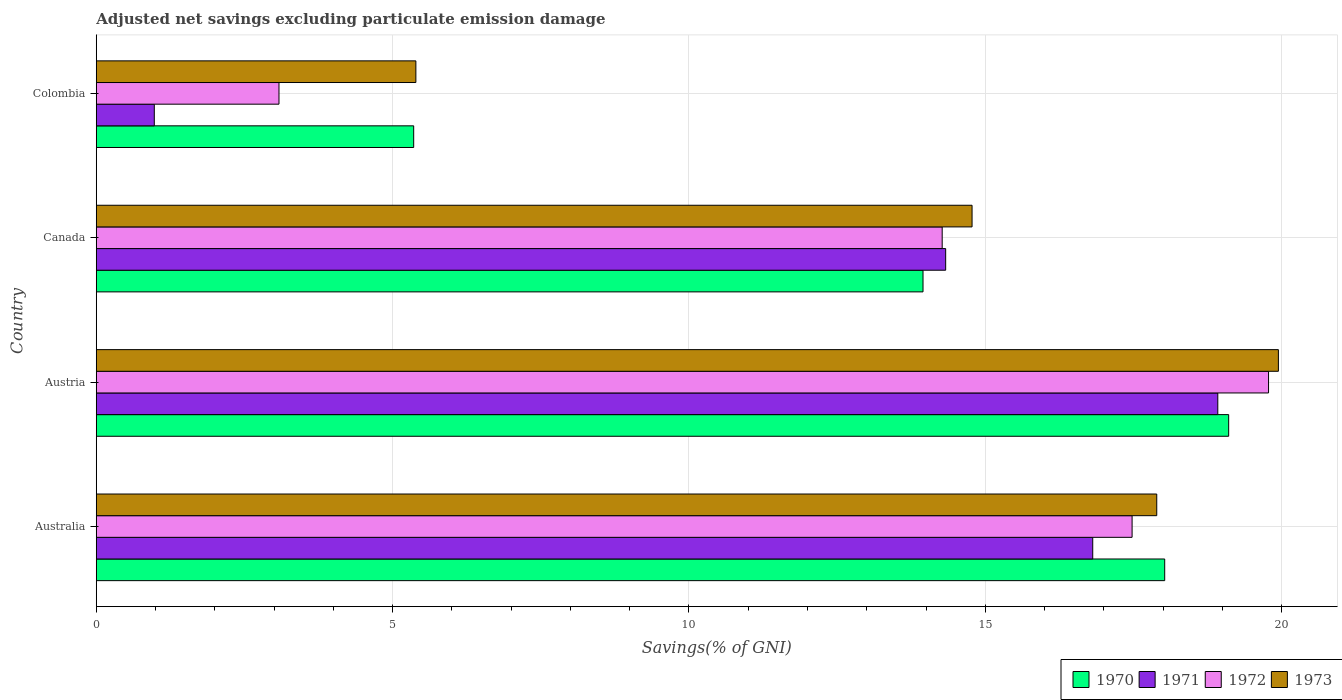How many different coloured bars are there?
Offer a very short reply. 4. Are the number of bars on each tick of the Y-axis equal?
Make the answer very short. Yes. How many bars are there on the 4th tick from the bottom?
Make the answer very short. 4. What is the label of the 4th group of bars from the top?
Provide a short and direct response. Australia. In how many cases, is the number of bars for a given country not equal to the number of legend labels?
Your response must be concise. 0. What is the adjusted net savings in 1970 in Colombia?
Your answer should be compact. 5.36. Across all countries, what is the maximum adjusted net savings in 1971?
Give a very brief answer. 18.92. Across all countries, what is the minimum adjusted net savings in 1971?
Provide a succinct answer. 0.98. In which country was the adjusted net savings in 1971 maximum?
Your response must be concise. Austria. What is the total adjusted net savings in 1970 in the graph?
Provide a short and direct response. 56.44. What is the difference between the adjusted net savings in 1970 in Austria and that in Canada?
Your answer should be compact. 5.16. What is the difference between the adjusted net savings in 1970 in Colombia and the adjusted net savings in 1972 in Canada?
Offer a very short reply. -8.92. What is the average adjusted net savings in 1973 per country?
Keep it short and to the point. 14.5. What is the difference between the adjusted net savings in 1970 and adjusted net savings in 1971 in Canada?
Offer a terse response. -0.38. In how many countries, is the adjusted net savings in 1973 greater than 5 %?
Offer a terse response. 4. What is the ratio of the adjusted net savings in 1972 in Australia to that in Austria?
Provide a short and direct response. 0.88. What is the difference between the highest and the second highest adjusted net savings in 1971?
Give a very brief answer. 2.11. What is the difference between the highest and the lowest adjusted net savings in 1973?
Provide a short and direct response. 14.55. Is it the case that in every country, the sum of the adjusted net savings in 1971 and adjusted net savings in 1973 is greater than the sum of adjusted net savings in 1972 and adjusted net savings in 1970?
Your answer should be very brief. No. What does the 3rd bar from the top in Colombia represents?
Offer a very short reply. 1971. Is it the case that in every country, the sum of the adjusted net savings in 1971 and adjusted net savings in 1973 is greater than the adjusted net savings in 1970?
Your answer should be very brief. Yes. How many bars are there?
Give a very brief answer. 16. Are the values on the major ticks of X-axis written in scientific E-notation?
Your response must be concise. No. Does the graph contain grids?
Provide a succinct answer. Yes. Where does the legend appear in the graph?
Offer a terse response. Bottom right. How are the legend labels stacked?
Ensure brevity in your answer.  Horizontal. What is the title of the graph?
Offer a terse response. Adjusted net savings excluding particulate emission damage. What is the label or title of the X-axis?
Make the answer very short. Savings(% of GNI). What is the Savings(% of GNI) of 1970 in Australia?
Offer a terse response. 18.03. What is the Savings(% of GNI) in 1971 in Australia?
Keep it short and to the point. 16.81. What is the Savings(% of GNI) in 1972 in Australia?
Provide a short and direct response. 17.48. What is the Savings(% of GNI) in 1973 in Australia?
Provide a succinct answer. 17.89. What is the Savings(% of GNI) in 1970 in Austria?
Ensure brevity in your answer.  19.11. What is the Savings(% of GNI) in 1971 in Austria?
Offer a terse response. 18.92. What is the Savings(% of GNI) in 1972 in Austria?
Your answer should be very brief. 19.78. What is the Savings(% of GNI) in 1973 in Austria?
Your answer should be very brief. 19.94. What is the Savings(% of GNI) of 1970 in Canada?
Make the answer very short. 13.95. What is the Savings(% of GNI) in 1971 in Canada?
Your response must be concise. 14.33. What is the Savings(% of GNI) of 1972 in Canada?
Ensure brevity in your answer.  14.27. What is the Savings(% of GNI) in 1973 in Canada?
Provide a short and direct response. 14.78. What is the Savings(% of GNI) in 1970 in Colombia?
Make the answer very short. 5.36. What is the Savings(% of GNI) in 1971 in Colombia?
Your response must be concise. 0.98. What is the Savings(% of GNI) of 1972 in Colombia?
Provide a short and direct response. 3.08. What is the Savings(% of GNI) of 1973 in Colombia?
Provide a short and direct response. 5.39. Across all countries, what is the maximum Savings(% of GNI) in 1970?
Ensure brevity in your answer.  19.11. Across all countries, what is the maximum Savings(% of GNI) in 1971?
Offer a terse response. 18.92. Across all countries, what is the maximum Savings(% of GNI) in 1972?
Your answer should be compact. 19.78. Across all countries, what is the maximum Savings(% of GNI) of 1973?
Provide a succinct answer. 19.94. Across all countries, what is the minimum Savings(% of GNI) in 1970?
Offer a terse response. 5.36. Across all countries, what is the minimum Savings(% of GNI) in 1971?
Provide a succinct answer. 0.98. Across all countries, what is the minimum Savings(% of GNI) of 1972?
Provide a succinct answer. 3.08. Across all countries, what is the minimum Savings(% of GNI) in 1973?
Ensure brevity in your answer.  5.39. What is the total Savings(% of GNI) of 1970 in the graph?
Your response must be concise. 56.44. What is the total Savings(% of GNI) in 1971 in the graph?
Provide a short and direct response. 51.04. What is the total Savings(% of GNI) in 1972 in the graph?
Offer a terse response. 54.61. What is the total Savings(% of GNI) in 1973 in the graph?
Offer a terse response. 58.01. What is the difference between the Savings(% of GNI) in 1970 in Australia and that in Austria?
Provide a succinct answer. -1.08. What is the difference between the Savings(% of GNI) of 1971 in Australia and that in Austria?
Make the answer very short. -2.11. What is the difference between the Savings(% of GNI) of 1972 in Australia and that in Austria?
Give a very brief answer. -2.3. What is the difference between the Savings(% of GNI) of 1973 in Australia and that in Austria?
Your response must be concise. -2.05. What is the difference between the Savings(% of GNI) of 1970 in Australia and that in Canada?
Your answer should be compact. 4.08. What is the difference between the Savings(% of GNI) in 1971 in Australia and that in Canada?
Provide a short and direct response. 2.48. What is the difference between the Savings(% of GNI) of 1972 in Australia and that in Canada?
Your response must be concise. 3.2. What is the difference between the Savings(% of GNI) in 1973 in Australia and that in Canada?
Keep it short and to the point. 3.12. What is the difference between the Savings(% of GNI) in 1970 in Australia and that in Colombia?
Provide a succinct answer. 12.67. What is the difference between the Savings(% of GNI) in 1971 in Australia and that in Colombia?
Your answer should be compact. 15.83. What is the difference between the Savings(% of GNI) in 1972 in Australia and that in Colombia?
Your answer should be compact. 14.39. What is the difference between the Savings(% of GNI) of 1973 in Australia and that in Colombia?
Your response must be concise. 12.5. What is the difference between the Savings(% of GNI) of 1970 in Austria and that in Canada?
Keep it short and to the point. 5.16. What is the difference between the Savings(% of GNI) of 1971 in Austria and that in Canada?
Provide a succinct answer. 4.59. What is the difference between the Savings(% of GNI) of 1972 in Austria and that in Canada?
Offer a very short reply. 5.51. What is the difference between the Savings(% of GNI) in 1973 in Austria and that in Canada?
Make the answer very short. 5.17. What is the difference between the Savings(% of GNI) of 1970 in Austria and that in Colombia?
Give a very brief answer. 13.75. What is the difference between the Savings(% of GNI) in 1971 in Austria and that in Colombia?
Offer a terse response. 17.94. What is the difference between the Savings(% of GNI) of 1972 in Austria and that in Colombia?
Your answer should be compact. 16.7. What is the difference between the Savings(% of GNI) in 1973 in Austria and that in Colombia?
Offer a very short reply. 14.55. What is the difference between the Savings(% of GNI) in 1970 in Canada and that in Colombia?
Keep it short and to the point. 8.59. What is the difference between the Savings(% of GNI) of 1971 in Canada and that in Colombia?
Your response must be concise. 13.35. What is the difference between the Savings(% of GNI) in 1972 in Canada and that in Colombia?
Ensure brevity in your answer.  11.19. What is the difference between the Savings(% of GNI) of 1973 in Canada and that in Colombia?
Make the answer very short. 9.38. What is the difference between the Savings(% of GNI) of 1970 in Australia and the Savings(% of GNI) of 1971 in Austria?
Provide a short and direct response. -0.9. What is the difference between the Savings(% of GNI) of 1970 in Australia and the Savings(% of GNI) of 1972 in Austria?
Make the answer very short. -1.75. What is the difference between the Savings(% of GNI) of 1970 in Australia and the Savings(% of GNI) of 1973 in Austria?
Give a very brief answer. -1.92. What is the difference between the Savings(% of GNI) in 1971 in Australia and the Savings(% of GNI) in 1972 in Austria?
Make the answer very short. -2.97. What is the difference between the Savings(% of GNI) of 1971 in Australia and the Savings(% of GNI) of 1973 in Austria?
Your response must be concise. -3.13. What is the difference between the Savings(% of GNI) of 1972 in Australia and the Savings(% of GNI) of 1973 in Austria?
Ensure brevity in your answer.  -2.47. What is the difference between the Savings(% of GNI) in 1970 in Australia and the Savings(% of GNI) in 1971 in Canada?
Make the answer very short. 3.7. What is the difference between the Savings(% of GNI) in 1970 in Australia and the Savings(% of GNI) in 1972 in Canada?
Your answer should be very brief. 3.75. What is the difference between the Savings(% of GNI) in 1970 in Australia and the Savings(% of GNI) in 1973 in Canada?
Your answer should be compact. 3.25. What is the difference between the Savings(% of GNI) in 1971 in Australia and the Savings(% of GNI) in 1972 in Canada?
Provide a short and direct response. 2.54. What is the difference between the Savings(% of GNI) in 1971 in Australia and the Savings(% of GNI) in 1973 in Canada?
Your answer should be compact. 2.04. What is the difference between the Savings(% of GNI) in 1970 in Australia and the Savings(% of GNI) in 1971 in Colombia?
Your answer should be compact. 17.05. What is the difference between the Savings(% of GNI) in 1970 in Australia and the Savings(% of GNI) in 1972 in Colombia?
Your answer should be very brief. 14.94. What is the difference between the Savings(% of GNI) in 1970 in Australia and the Savings(% of GNI) in 1973 in Colombia?
Keep it short and to the point. 12.63. What is the difference between the Savings(% of GNI) in 1971 in Australia and the Savings(% of GNI) in 1972 in Colombia?
Offer a very short reply. 13.73. What is the difference between the Savings(% of GNI) of 1971 in Australia and the Savings(% of GNI) of 1973 in Colombia?
Provide a succinct answer. 11.42. What is the difference between the Savings(% of GNI) of 1972 in Australia and the Savings(% of GNI) of 1973 in Colombia?
Make the answer very short. 12.08. What is the difference between the Savings(% of GNI) of 1970 in Austria and the Savings(% of GNI) of 1971 in Canada?
Keep it short and to the point. 4.77. What is the difference between the Savings(% of GNI) of 1970 in Austria and the Savings(% of GNI) of 1972 in Canada?
Provide a succinct answer. 4.83. What is the difference between the Savings(% of GNI) in 1970 in Austria and the Savings(% of GNI) in 1973 in Canada?
Offer a very short reply. 4.33. What is the difference between the Savings(% of GNI) in 1971 in Austria and the Savings(% of GNI) in 1972 in Canada?
Offer a very short reply. 4.65. What is the difference between the Savings(% of GNI) of 1971 in Austria and the Savings(% of GNI) of 1973 in Canada?
Your response must be concise. 4.15. What is the difference between the Savings(% of GNI) of 1972 in Austria and the Savings(% of GNI) of 1973 in Canada?
Offer a very short reply. 5. What is the difference between the Savings(% of GNI) in 1970 in Austria and the Savings(% of GNI) in 1971 in Colombia?
Keep it short and to the point. 18.13. What is the difference between the Savings(% of GNI) in 1970 in Austria and the Savings(% of GNI) in 1972 in Colombia?
Your answer should be compact. 16.02. What is the difference between the Savings(% of GNI) of 1970 in Austria and the Savings(% of GNI) of 1973 in Colombia?
Provide a short and direct response. 13.71. What is the difference between the Savings(% of GNI) in 1971 in Austria and the Savings(% of GNI) in 1972 in Colombia?
Offer a terse response. 15.84. What is the difference between the Savings(% of GNI) in 1971 in Austria and the Savings(% of GNI) in 1973 in Colombia?
Ensure brevity in your answer.  13.53. What is the difference between the Savings(% of GNI) of 1972 in Austria and the Savings(% of GNI) of 1973 in Colombia?
Your response must be concise. 14.39. What is the difference between the Savings(% of GNI) of 1970 in Canada and the Savings(% of GNI) of 1971 in Colombia?
Ensure brevity in your answer.  12.97. What is the difference between the Savings(% of GNI) in 1970 in Canada and the Savings(% of GNI) in 1972 in Colombia?
Make the answer very short. 10.87. What is the difference between the Savings(% of GNI) of 1970 in Canada and the Savings(% of GNI) of 1973 in Colombia?
Offer a very short reply. 8.56. What is the difference between the Savings(% of GNI) of 1971 in Canada and the Savings(% of GNI) of 1972 in Colombia?
Provide a succinct answer. 11.25. What is the difference between the Savings(% of GNI) of 1971 in Canada and the Savings(% of GNI) of 1973 in Colombia?
Make the answer very short. 8.94. What is the difference between the Savings(% of GNI) in 1972 in Canada and the Savings(% of GNI) in 1973 in Colombia?
Offer a terse response. 8.88. What is the average Savings(% of GNI) of 1970 per country?
Ensure brevity in your answer.  14.11. What is the average Savings(% of GNI) in 1971 per country?
Make the answer very short. 12.76. What is the average Savings(% of GNI) in 1972 per country?
Ensure brevity in your answer.  13.65. What is the average Savings(% of GNI) of 1973 per country?
Your response must be concise. 14.5. What is the difference between the Savings(% of GNI) in 1970 and Savings(% of GNI) in 1971 in Australia?
Make the answer very short. 1.21. What is the difference between the Savings(% of GNI) in 1970 and Savings(% of GNI) in 1972 in Australia?
Offer a very short reply. 0.55. What is the difference between the Savings(% of GNI) in 1970 and Savings(% of GNI) in 1973 in Australia?
Your response must be concise. 0.13. What is the difference between the Savings(% of GNI) of 1971 and Savings(% of GNI) of 1972 in Australia?
Ensure brevity in your answer.  -0.66. What is the difference between the Savings(% of GNI) in 1971 and Savings(% of GNI) in 1973 in Australia?
Offer a terse response. -1.08. What is the difference between the Savings(% of GNI) in 1972 and Savings(% of GNI) in 1973 in Australia?
Ensure brevity in your answer.  -0.42. What is the difference between the Savings(% of GNI) in 1970 and Savings(% of GNI) in 1971 in Austria?
Give a very brief answer. 0.18. What is the difference between the Savings(% of GNI) of 1970 and Savings(% of GNI) of 1972 in Austria?
Offer a terse response. -0.67. What is the difference between the Savings(% of GNI) of 1970 and Savings(% of GNI) of 1973 in Austria?
Make the answer very short. -0.84. What is the difference between the Savings(% of GNI) of 1971 and Savings(% of GNI) of 1972 in Austria?
Ensure brevity in your answer.  -0.86. What is the difference between the Savings(% of GNI) in 1971 and Savings(% of GNI) in 1973 in Austria?
Offer a terse response. -1.02. What is the difference between the Savings(% of GNI) in 1972 and Savings(% of GNI) in 1973 in Austria?
Offer a terse response. -0.17. What is the difference between the Savings(% of GNI) of 1970 and Savings(% of GNI) of 1971 in Canada?
Provide a succinct answer. -0.38. What is the difference between the Savings(% of GNI) of 1970 and Savings(% of GNI) of 1972 in Canada?
Your answer should be very brief. -0.32. What is the difference between the Savings(% of GNI) in 1970 and Savings(% of GNI) in 1973 in Canada?
Your answer should be very brief. -0.83. What is the difference between the Savings(% of GNI) of 1971 and Savings(% of GNI) of 1972 in Canada?
Provide a short and direct response. 0.06. What is the difference between the Savings(% of GNI) in 1971 and Savings(% of GNI) in 1973 in Canada?
Provide a succinct answer. -0.45. What is the difference between the Savings(% of GNI) in 1972 and Savings(% of GNI) in 1973 in Canada?
Keep it short and to the point. -0.5. What is the difference between the Savings(% of GNI) in 1970 and Savings(% of GNI) in 1971 in Colombia?
Offer a terse response. 4.38. What is the difference between the Savings(% of GNI) in 1970 and Savings(% of GNI) in 1972 in Colombia?
Offer a terse response. 2.27. What is the difference between the Savings(% of GNI) in 1970 and Savings(% of GNI) in 1973 in Colombia?
Give a very brief answer. -0.04. What is the difference between the Savings(% of GNI) in 1971 and Savings(% of GNI) in 1972 in Colombia?
Give a very brief answer. -2.1. What is the difference between the Savings(% of GNI) of 1971 and Savings(% of GNI) of 1973 in Colombia?
Provide a succinct answer. -4.41. What is the difference between the Savings(% of GNI) of 1972 and Savings(% of GNI) of 1973 in Colombia?
Offer a terse response. -2.31. What is the ratio of the Savings(% of GNI) in 1970 in Australia to that in Austria?
Provide a short and direct response. 0.94. What is the ratio of the Savings(% of GNI) of 1971 in Australia to that in Austria?
Make the answer very short. 0.89. What is the ratio of the Savings(% of GNI) of 1972 in Australia to that in Austria?
Ensure brevity in your answer.  0.88. What is the ratio of the Savings(% of GNI) in 1973 in Australia to that in Austria?
Provide a succinct answer. 0.9. What is the ratio of the Savings(% of GNI) of 1970 in Australia to that in Canada?
Keep it short and to the point. 1.29. What is the ratio of the Savings(% of GNI) in 1971 in Australia to that in Canada?
Ensure brevity in your answer.  1.17. What is the ratio of the Savings(% of GNI) of 1972 in Australia to that in Canada?
Your answer should be compact. 1.22. What is the ratio of the Savings(% of GNI) in 1973 in Australia to that in Canada?
Provide a short and direct response. 1.21. What is the ratio of the Savings(% of GNI) of 1970 in Australia to that in Colombia?
Your answer should be very brief. 3.37. What is the ratio of the Savings(% of GNI) in 1971 in Australia to that in Colombia?
Provide a succinct answer. 17.17. What is the ratio of the Savings(% of GNI) of 1972 in Australia to that in Colombia?
Provide a short and direct response. 5.67. What is the ratio of the Savings(% of GNI) in 1973 in Australia to that in Colombia?
Keep it short and to the point. 3.32. What is the ratio of the Savings(% of GNI) of 1970 in Austria to that in Canada?
Provide a short and direct response. 1.37. What is the ratio of the Savings(% of GNI) of 1971 in Austria to that in Canada?
Provide a short and direct response. 1.32. What is the ratio of the Savings(% of GNI) of 1972 in Austria to that in Canada?
Your answer should be very brief. 1.39. What is the ratio of the Savings(% of GNI) of 1973 in Austria to that in Canada?
Keep it short and to the point. 1.35. What is the ratio of the Savings(% of GNI) in 1970 in Austria to that in Colombia?
Provide a succinct answer. 3.57. What is the ratio of the Savings(% of GNI) in 1971 in Austria to that in Colombia?
Give a very brief answer. 19.32. What is the ratio of the Savings(% of GNI) in 1972 in Austria to that in Colombia?
Ensure brevity in your answer.  6.42. What is the ratio of the Savings(% of GNI) in 1973 in Austria to that in Colombia?
Offer a terse response. 3.7. What is the ratio of the Savings(% of GNI) in 1970 in Canada to that in Colombia?
Your answer should be compact. 2.6. What is the ratio of the Savings(% of GNI) in 1971 in Canada to that in Colombia?
Your answer should be very brief. 14.64. What is the ratio of the Savings(% of GNI) of 1972 in Canada to that in Colombia?
Give a very brief answer. 4.63. What is the ratio of the Savings(% of GNI) of 1973 in Canada to that in Colombia?
Your response must be concise. 2.74. What is the difference between the highest and the second highest Savings(% of GNI) of 1970?
Your answer should be very brief. 1.08. What is the difference between the highest and the second highest Savings(% of GNI) of 1971?
Ensure brevity in your answer.  2.11. What is the difference between the highest and the second highest Savings(% of GNI) of 1972?
Make the answer very short. 2.3. What is the difference between the highest and the second highest Savings(% of GNI) of 1973?
Keep it short and to the point. 2.05. What is the difference between the highest and the lowest Savings(% of GNI) of 1970?
Give a very brief answer. 13.75. What is the difference between the highest and the lowest Savings(% of GNI) of 1971?
Offer a very short reply. 17.94. What is the difference between the highest and the lowest Savings(% of GNI) in 1972?
Provide a short and direct response. 16.7. What is the difference between the highest and the lowest Savings(% of GNI) of 1973?
Provide a succinct answer. 14.55. 